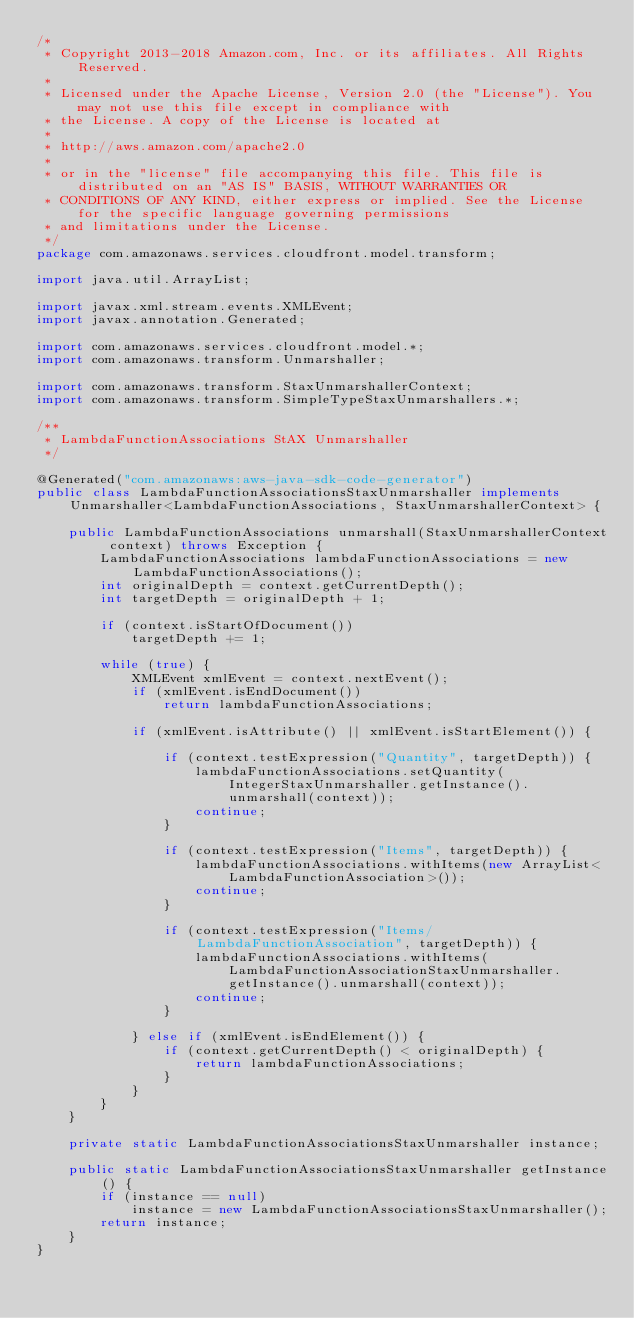Convert code to text. <code><loc_0><loc_0><loc_500><loc_500><_Java_>/*
 * Copyright 2013-2018 Amazon.com, Inc. or its affiliates. All Rights Reserved.
 * 
 * Licensed under the Apache License, Version 2.0 (the "License"). You may not use this file except in compliance with
 * the License. A copy of the License is located at
 * 
 * http://aws.amazon.com/apache2.0
 * 
 * or in the "license" file accompanying this file. This file is distributed on an "AS IS" BASIS, WITHOUT WARRANTIES OR
 * CONDITIONS OF ANY KIND, either express or implied. See the License for the specific language governing permissions
 * and limitations under the License.
 */
package com.amazonaws.services.cloudfront.model.transform;

import java.util.ArrayList;

import javax.xml.stream.events.XMLEvent;
import javax.annotation.Generated;

import com.amazonaws.services.cloudfront.model.*;
import com.amazonaws.transform.Unmarshaller;

import com.amazonaws.transform.StaxUnmarshallerContext;
import com.amazonaws.transform.SimpleTypeStaxUnmarshallers.*;

/**
 * LambdaFunctionAssociations StAX Unmarshaller
 */

@Generated("com.amazonaws:aws-java-sdk-code-generator")
public class LambdaFunctionAssociationsStaxUnmarshaller implements Unmarshaller<LambdaFunctionAssociations, StaxUnmarshallerContext> {

    public LambdaFunctionAssociations unmarshall(StaxUnmarshallerContext context) throws Exception {
        LambdaFunctionAssociations lambdaFunctionAssociations = new LambdaFunctionAssociations();
        int originalDepth = context.getCurrentDepth();
        int targetDepth = originalDepth + 1;

        if (context.isStartOfDocument())
            targetDepth += 1;

        while (true) {
            XMLEvent xmlEvent = context.nextEvent();
            if (xmlEvent.isEndDocument())
                return lambdaFunctionAssociations;

            if (xmlEvent.isAttribute() || xmlEvent.isStartElement()) {

                if (context.testExpression("Quantity", targetDepth)) {
                    lambdaFunctionAssociations.setQuantity(IntegerStaxUnmarshaller.getInstance().unmarshall(context));
                    continue;
                }

                if (context.testExpression("Items", targetDepth)) {
                    lambdaFunctionAssociations.withItems(new ArrayList<LambdaFunctionAssociation>());
                    continue;
                }

                if (context.testExpression("Items/LambdaFunctionAssociation", targetDepth)) {
                    lambdaFunctionAssociations.withItems(LambdaFunctionAssociationStaxUnmarshaller.getInstance().unmarshall(context));
                    continue;
                }

            } else if (xmlEvent.isEndElement()) {
                if (context.getCurrentDepth() < originalDepth) {
                    return lambdaFunctionAssociations;
                }
            }
        }
    }

    private static LambdaFunctionAssociationsStaxUnmarshaller instance;

    public static LambdaFunctionAssociationsStaxUnmarshaller getInstance() {
        if (instance == null)
            instance = new LambdaFunctionAssociationsStaxUnmarshaller();
        return instance;
    }
}
</code> 